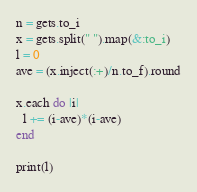Convert code to text. <code><loc_0><loc_0><loc_500><loc_500><_Ruby_>n = gets.to_i
x = gets.split(" ").map(&:to_i)
l = 0
ave = (x.inject(:+)/n.to_f).round

x.each do |i|
  l += (i-ave)*(i-ave)
end

print(l)</code> 